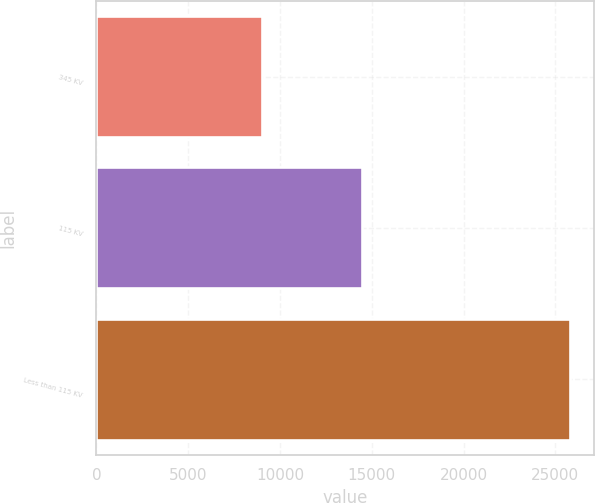Convert chart. <chart><loc_0><loc_0><loc_500><loc_500><bar_chart><fcel>345 KV<fcel>115 KV<fcel>Less than 115 KV<nl><fcel>9028<fcel>14493<fcel>25820<nl></chart> 